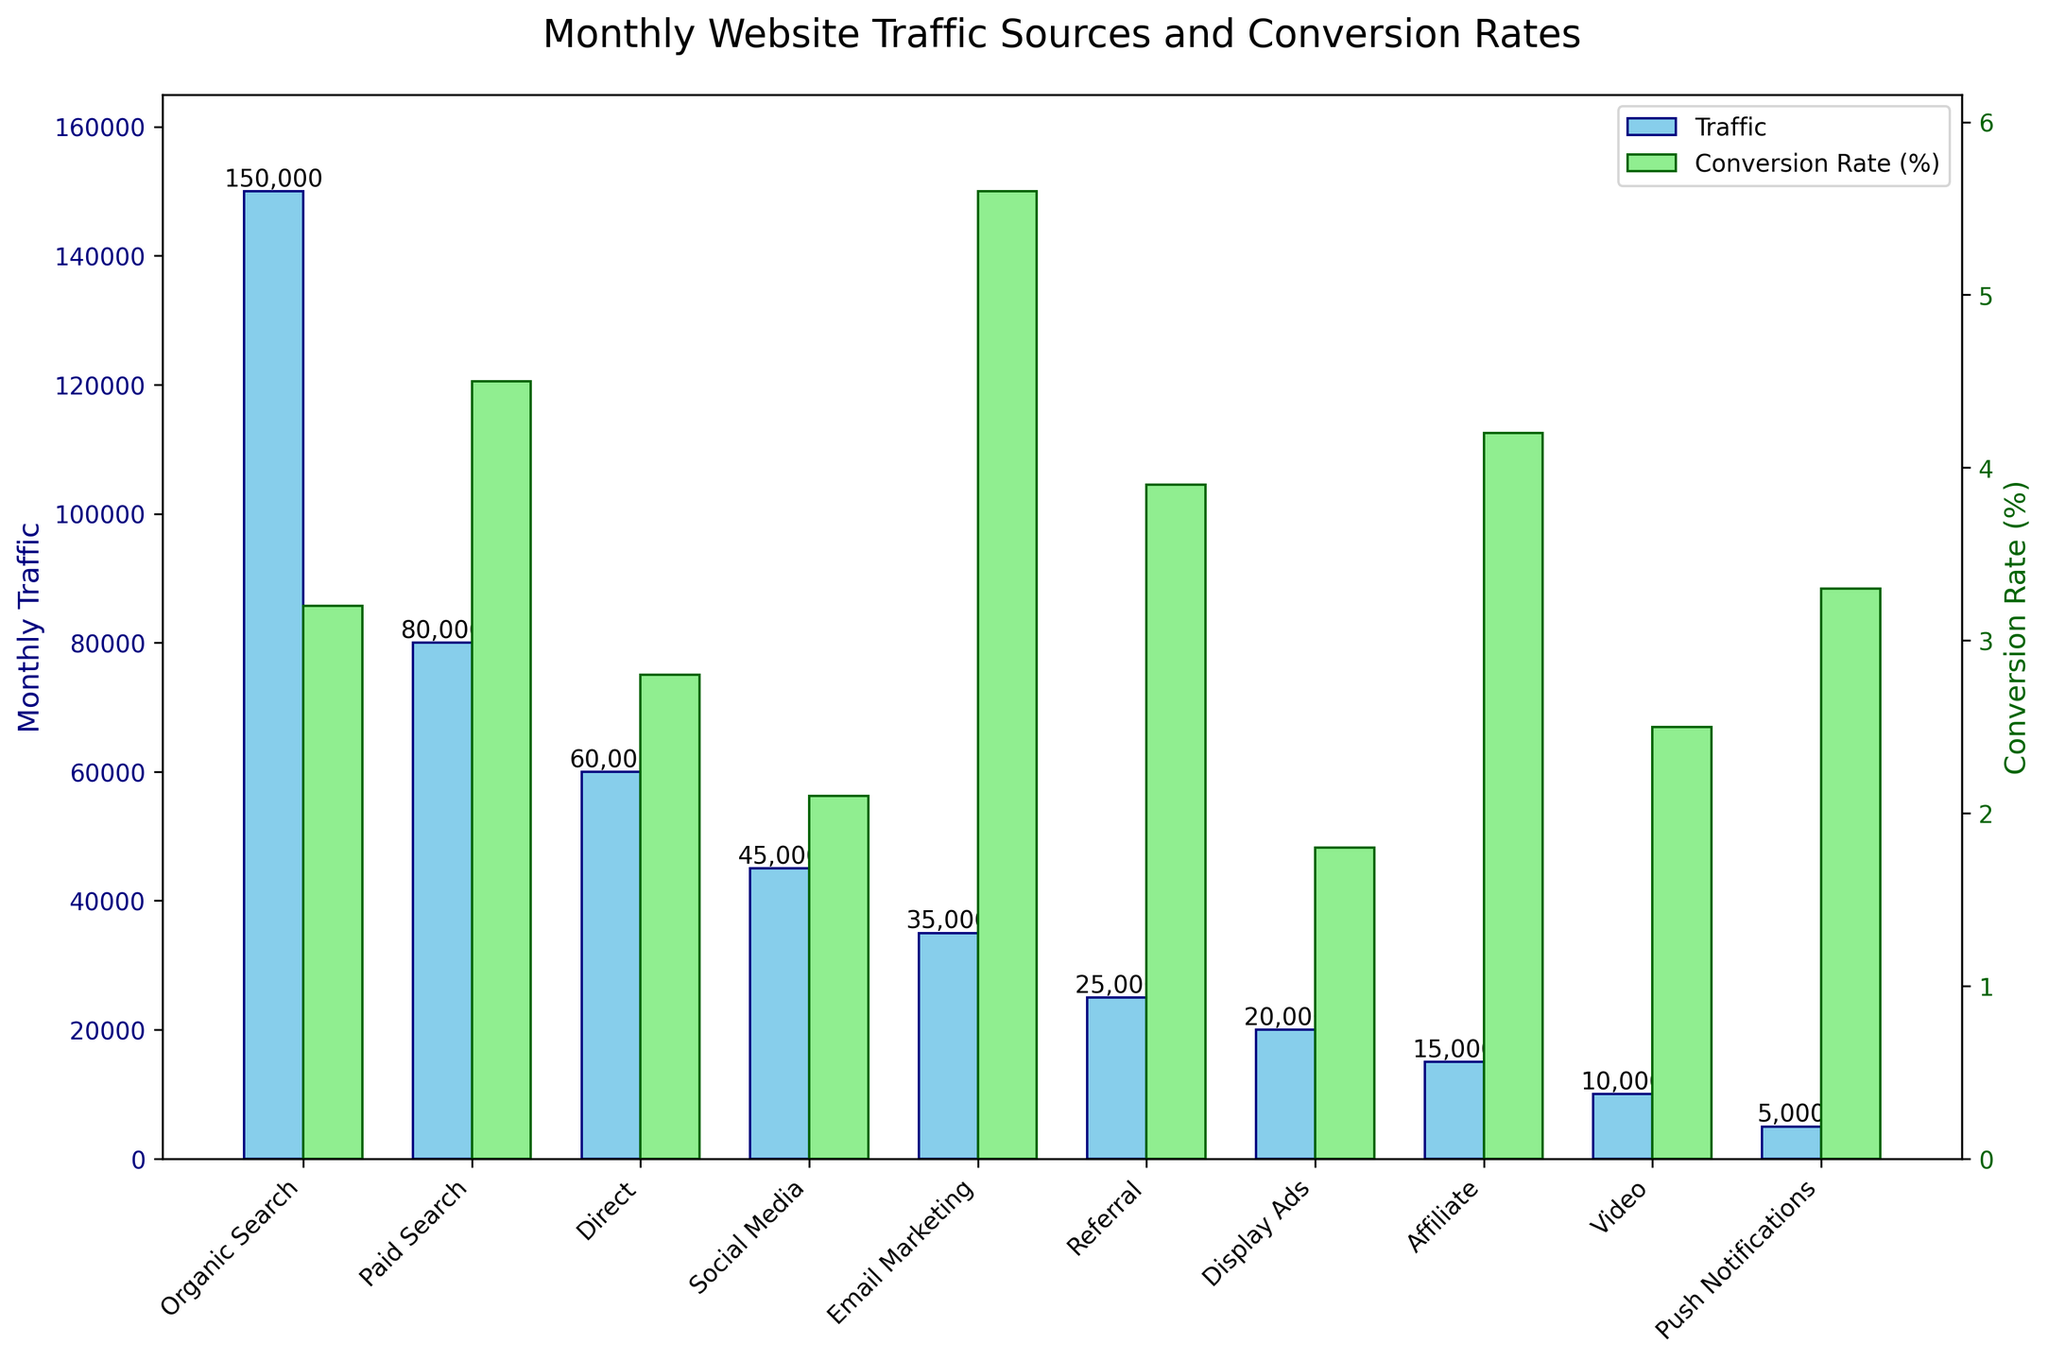Which traffic source has the highest conversion rate? Look for the bar with the highest height in the conversion rate series (the green bars). Compare the heights of each bar in this series to find the tallest one, which corresponds to the highest conversion rate.
Answer: Email Marketing What is the total monthly traffic from Organic Search and Paid Search combined? Locate the traffic values for Organic Search and Paid Search from the blue bars. The values are 150,000 and 80,000, respectively. Add these two numbers together to get the total monthly traffic.
Answer: 230,000 Which traffic source has a higher conversion rate, Social Media or Display Ads? Find the green bars corresponding to Social Media and Display Ads. Compare the heights of these two bars to determine which is higher.
Answer: Social Media What is the difference in conversion rates between the highest and lowest converting traffic sources? Identify the highest and lowest conversion rates (Email Marketing at 5.6% and Display Ads at 1.8%, respectively). Subtract the lowest conversion rate from the highest.
Answer: 3.8 How many traffic sources have a conversion rate higher than 4%? Look at the height of the green bars and find how many bars are above the 4% mark. Count these bars (Paid Search, Email Marketing, Affiliate).
Answer: 3 What is the average conversion rate of all traffic sources? Sum up all conversion rates: 3.2 + 4.5 + 2.8 + 2.1 + 5.6 + 3.9 + 1.8 + 4.2 + 2.5 + 3.3 = 33.9. Count the number of sources (10) and divide the total by this number to get the average.
Answer: 3.39 Which traffic source has the least amount of monthly traffic? Look at the shortest blue bar to find the traffic source with the least amount of traffic.
Answer: Push Notifications By how much does Paid Search’s traffic exceed that of Display Ads? Find the traffic values for Paid Search (80,000) and Display Ads (20,000). Subtract the traffic value of Display Ads from that of Paid Search.
Answer: 60,000 If Affiliate traffic doubles, what will its new traffic be? The current traffic for Affiliate is 15,000. Doubling this traffic results in 2 * 15,000 = 30,000.
Answer: 30,000 